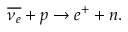Convert formula to latex. <formula><loc_0><loc_0><loc_500><loc_500>\overline { { \nu _ { e } } } + p \to e ^ { + } + n .</formula> 